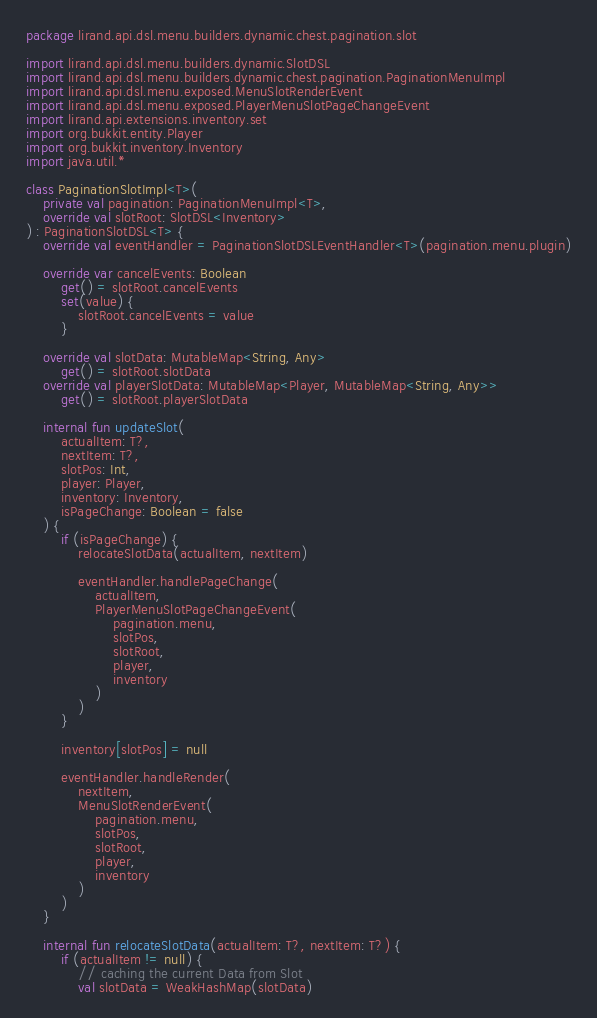<code> <loc_0><loc_0><loc_500><loc_500><_Kotlin_>package lirand.api.dsl.menu.builders.dynamic.chest.pagination.slot

import lirand.api.dsl.menu.builders.dynamic.SlotDSL
import lirand.api.dsl.menu.builders.dynamic.chest.pagination.PaginationMenuImpl
import lirand.api.dsl.menu.exposed.MenuSlotRenderEvent
import lirand.api.dsl.menu.exposed.PlayerMenuSlotPageChangeEvent
import lirand.api.extensions.inventory.set
import org.bukkit.entity.Player
import org.bukkit.inventory.Inventory
import java.util.*

class PaginationSlotImpl<T>(
	private val pagination: PaginationMenuImpl<T>,
	override val slotRoot: SlotDSL<Inventory>
) : PaginationSlotDSL<T> {
	override val eventHandler = PaginationSlotDSLEventHandler<T>(pagination.menu.plugin)

	override var cancelEvents: Boolean
		get() = slotRoot.cancelEvents
		set(value) {
			slotRoot.cancelEvents = value
		}

	override val slotData: MutableMap<String, Any>
		get() = slotRoot.slotData
	override val playerSlotData: MutableMap<Player, MutableMap<String, Any>>
		get() = slotRoot.playerSlotData

	internal fun updateSlot(
		actualItem: T?,
		nextItem: T?,
		slotPos: Int,
		player: Player,
		inventory: Inventory,
		isPageChange: Boolean = false
	) {
		if (isPageChange) {
			relocateSlotData(actualItem, nextItem)

			eventHandler.handlePageChange(
				actualItem,
				PlayerMenuSlotPageChangeEvent(
					pagination.menu,
					slotPos,
					slotRoot,
					player,
					inventory
				)
			)
		}

		inventory[slotPos] = null

		eventHandler.handleRender(
			nextItem,
			MenuSlotRenderEvent(
				pagination.menu,
				slotPos,
				slotRoot,
				player,
				inventory
			)
		)
	}

	internal fun relocateSlotData(actualItem: T?, nextItem: T?) {
		if (actualItem != null) {
			// caching the current Data from Slot
			val slotData = WeakHashMap(slotData)</code> 